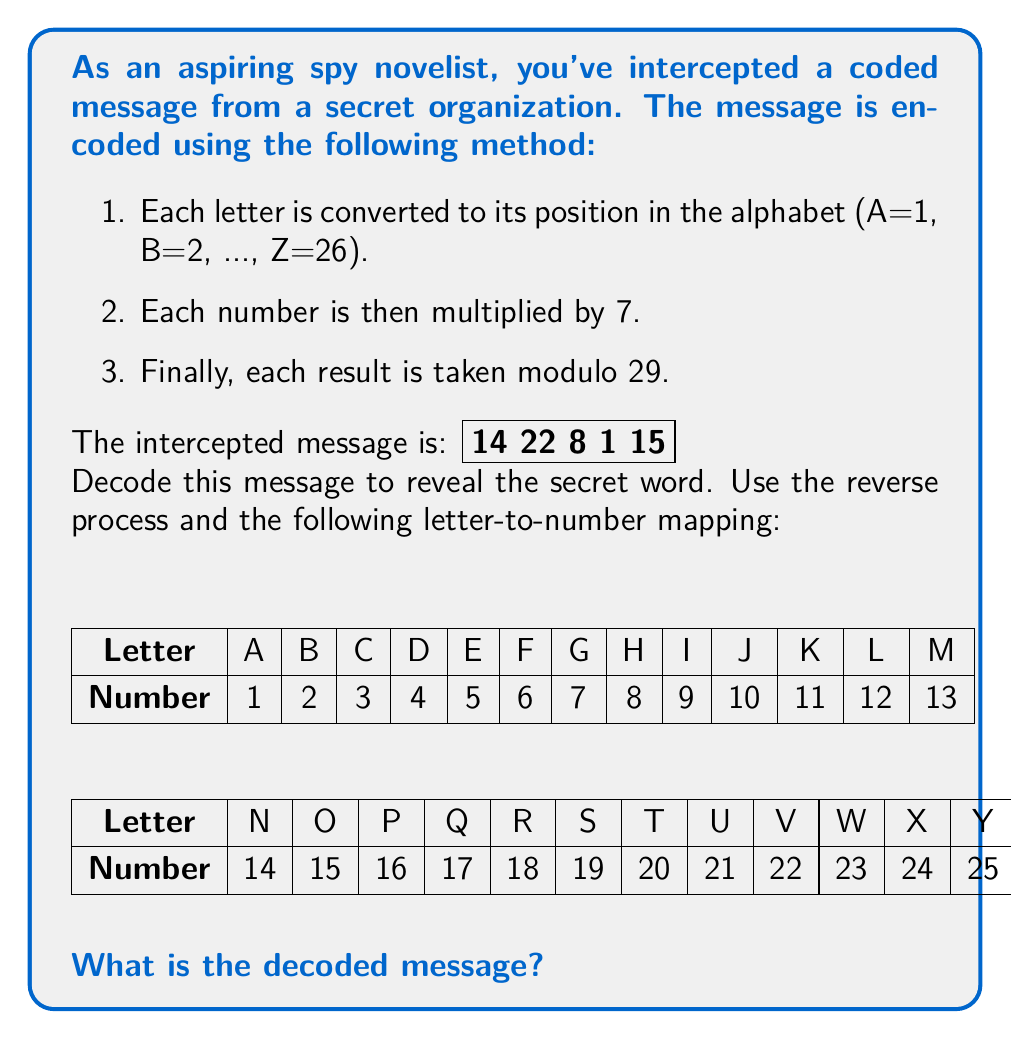Show me your answer to this math problem. To decode the message, we need to reverse the encoding process for each number:

1. For each number $n$ in the coded message, we need to find $x$ such that $(7x) \bmod 29 = n$.
2. This is equivalent to solving the congruence $7x \equiv n \pmod{29}$.
3. We can use the modular multiplicative inverse of 7 (mod 29) to solve this.
4. The modular multiplicative inverse of 7 (mod 29) is 25, because $7 \cdot 25 \equiv 1 \pmod{29}$.
5. So, we multiply each number by 25 and take mod 29 to get the original position in the alphabet.

Let's decode each number:

14: $(14 \cdot 25) \bmod 29 = 350 \bmod 29 = 5$ (E)
22: $(22 \cdot 25) \bmod 29 = 550 \bmod 29 = 26$ (Z)
8: $(8 \cdot 25) \bmod 29 = 200 \bmod 29 = 26$ (Z)
1: $(1 \cdot 25) \bmod 29 = 25 \bmod 29 = 25$ (Y)
15: $(15 \cdot 25) \bmod 29 = 375 \bmod 29 = 26$ (Z)

Therefore, the decoded message is EZZYY.
Answer: EZZYY 